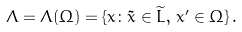<formula> <loc_0><loc_0><loc_500><loc_500>\Lambda = \Lambda ( \Omega ) = \{ x \colon \tilde { x } \in \widetilde { L } , \, x ^ { \prime } \in \Omega \} \, .</formula> 